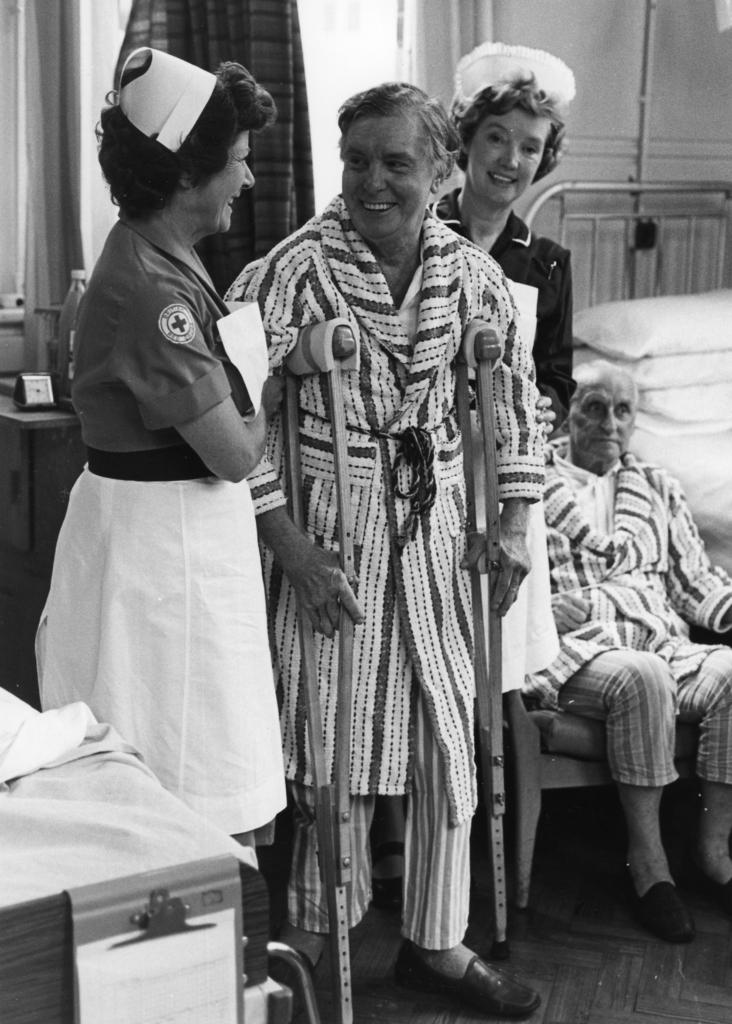What is the main subject in the foreground of the image? There is a person in the foreground of the image. What is the person using for support? The person is using a crutch for support. How many women are present in the image? There are two women in the image. Where is the first woman positioned in relation to the person? The first woman is on the left side of the person. Where is the second woman positioned in relation to the person? The second woman is on the right side of the person. What are the women doing in the image? Both women are holding the person. What type of business is the person attempting to open in the image? There is no indication of a business or an attempt to open one in the image. 